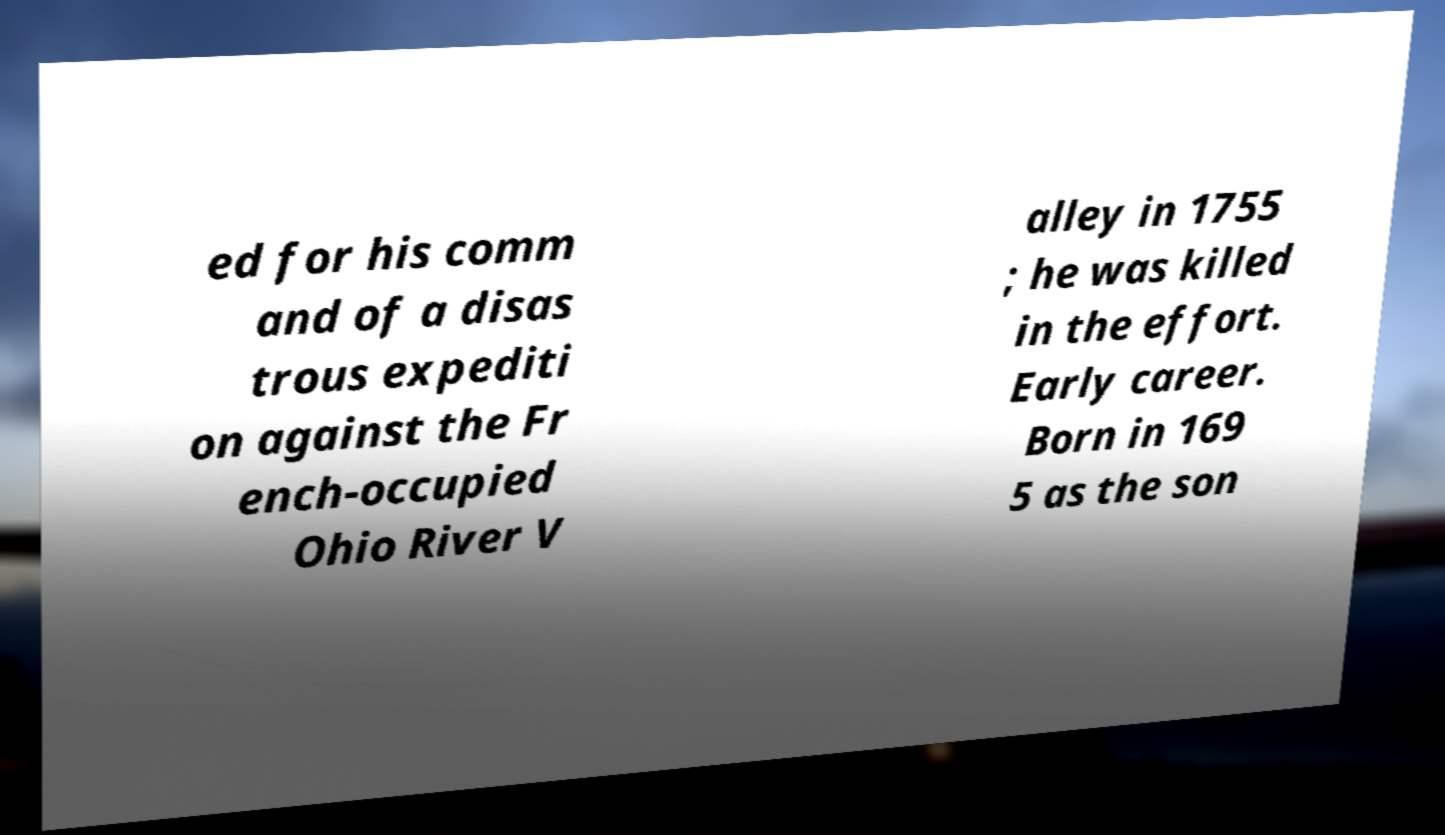For documentation purposes, I need the text within this image transcribed. Could you provide that? ed for his comm and of a disas trous expediti on against the Fr ench-occupied Ohio River V alley in 1755 ; he was killed in the effort. Early career. Born in 169 5 as the son 